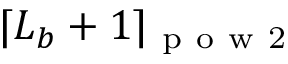<formula> <loc_0><loc_0><loc_500><loc_500>\lceil L _ { b } + 1 \rceil _ { p o w 2 }</formula> 